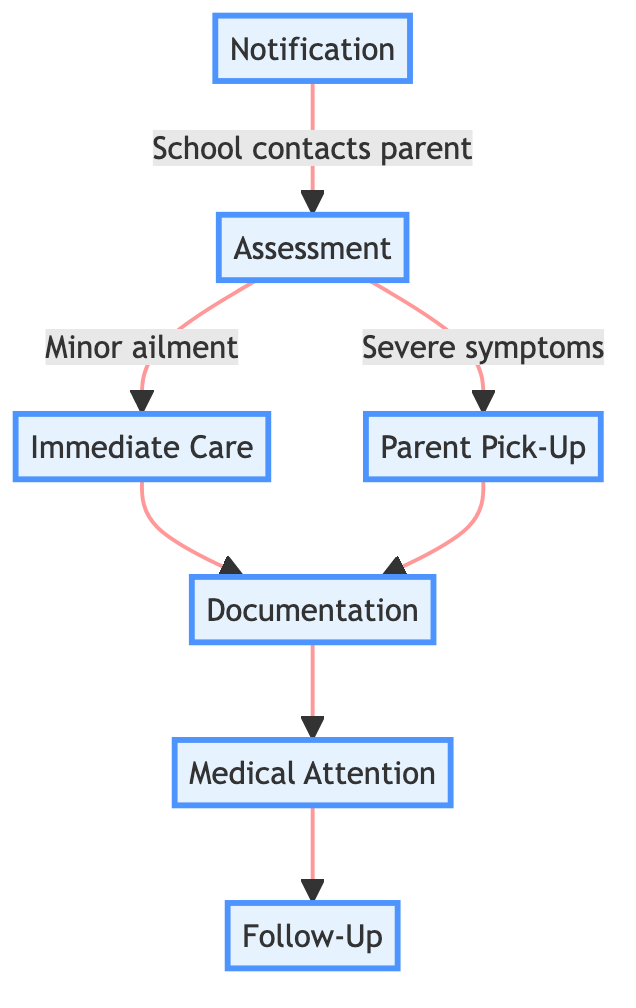What is the first step in handling a child's illness during school hours? The first step in the pathway is "Notification," where the school reception contacts the parent about the child's illness.
Answer: Notification How many steps are in the diagram? The diagram includes a total of seven distinct steps outlined in the clinical pathway.
Answer: Seven What happens after the "Assessment" step if the assessment reveals a minor ailment? If the initial assessment indicates a minor ailment, the next step is "Immediate Care," where minor ailments are treated at the school.
Answer: Immediate Care What is required after "Parent Pick-Up"? After "Parent Pick-Up," the next step is "Documentation," where the school provides a written report of the incident and care provided.
Answer: Documentation What is the final step in the pathway? The final step of the clinical pathway is "Follow-Up," where parents are advised to inform the school about the child's health status.
Answer: Follow-Up If a child has severe symptoms during the assessment, what step do parents take? If severe symptoms are found, parents proceed to "Parent Pick-Up," where they pick up their child from school.
Answer: Parent Pick-Up Is "Medical Attention" a step that follows "Immediate Care"? No, "Medical Attention" follows "Documentation," indicating a visit to a healthcare provider if necessary, rather than following "Immediate Care."
Answer: No What type of care is provided in the "Immediate Care" step? The type of care provided in "Immediate Care" is for minor ailments, while parents are advised to pick up their child for severe symptoms.
Answer: Minor ailments 